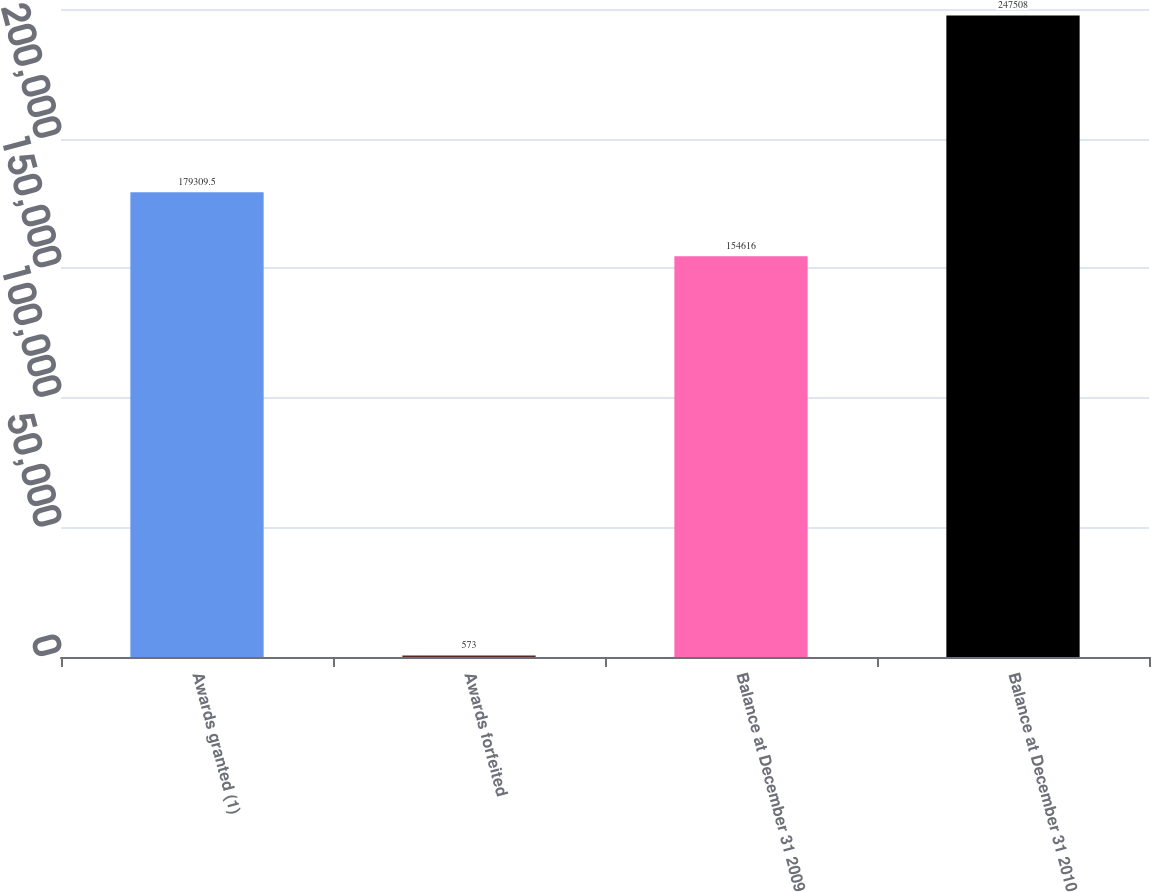<chart> <loc_0><loc_0><loc_500><loc_500><bar_chart><fcel>Awards granted (1)<fcel>Awards forfeited<fcel>Balance at December 31 2009<fcel>Balance at December 31 2010<nl><fcel>179310<fcel>573<fcel>154616<fcel>247508<nl></chart> 